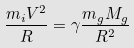<formula> <loc_0><loc_0><loc_500><loc_500>\frac { m _ { i } V ^ { 2 } } { R } = { \gamma } \frac { m _ { g } M _ { g } } { R ^ { 2 } }</formula> 